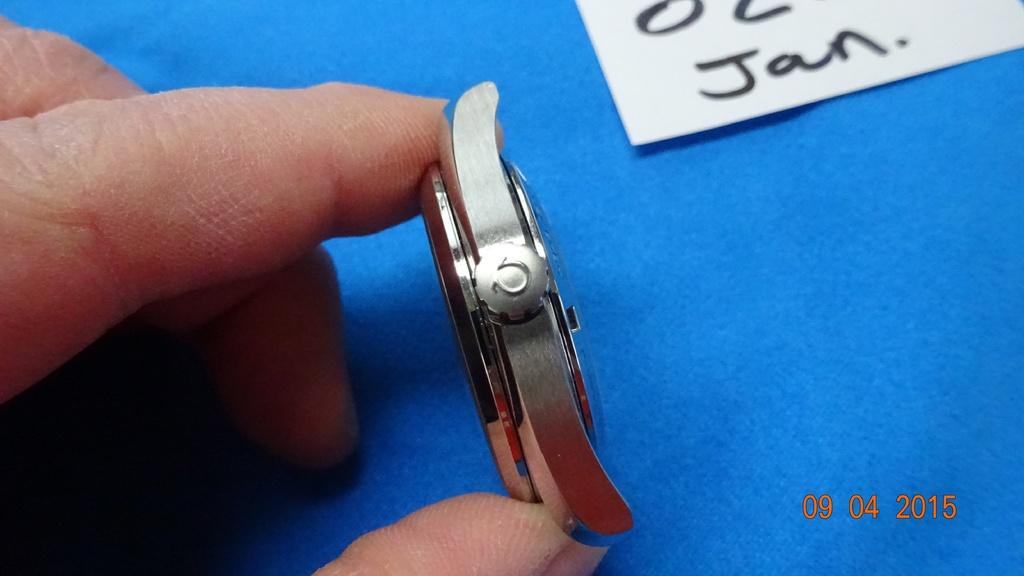Provide a one-sentence caption for the provided image. A person is holding a watch face sideways and a card on the table has the abbreviation for January on it. 